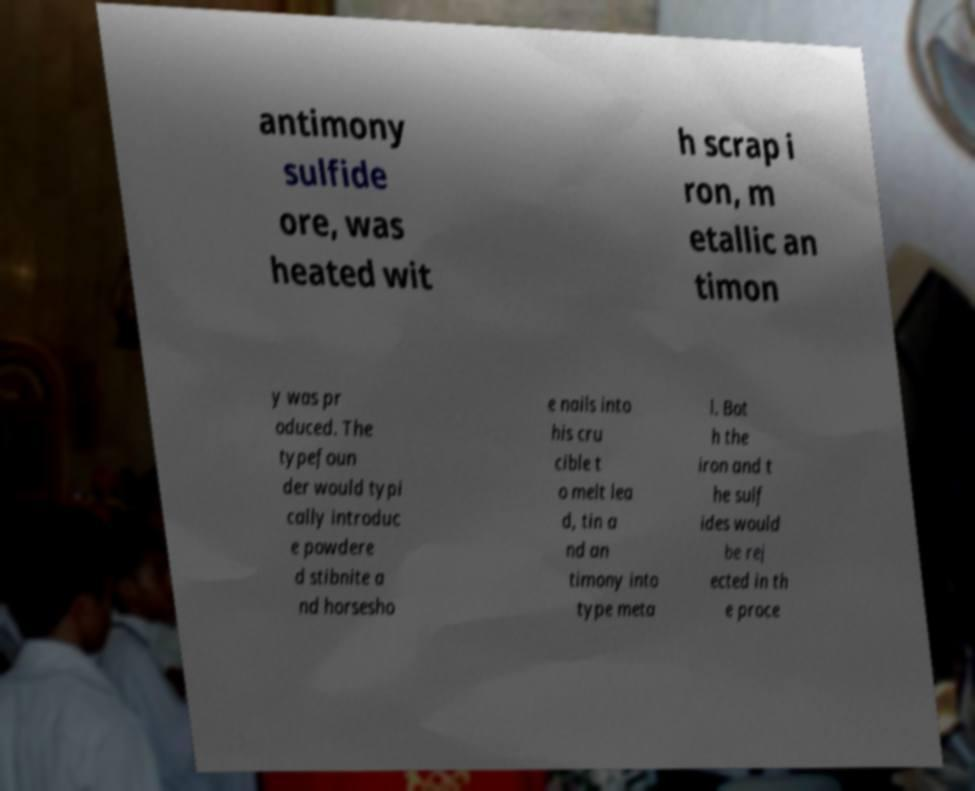Please read and relay the text visible in this image. What does it say? antimony sulfide ore, was heated wit h scrap i ron, m etallic an timon y was pr oduced. The typefoun der would typi cally introduc e powdere d stibnite a nd horsesho e nails into his cru cible t o melt lea d, tin a nd an timony into type meta l. Bot h the iron and t he sulf ides would be rej ected in th e proce 